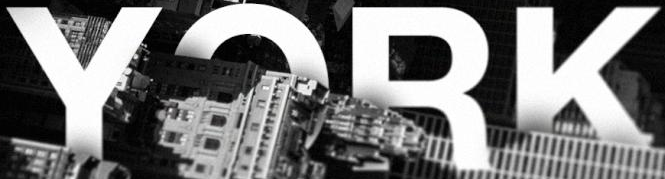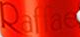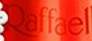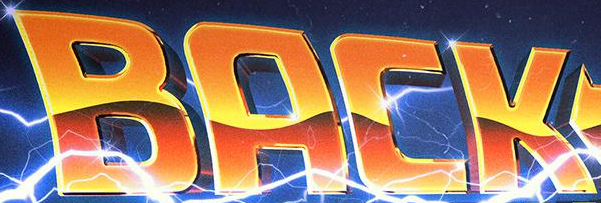Transcribe the words shown in these images in order, separated by a semicolon. YORK; Raffae; Raffael; BACK 